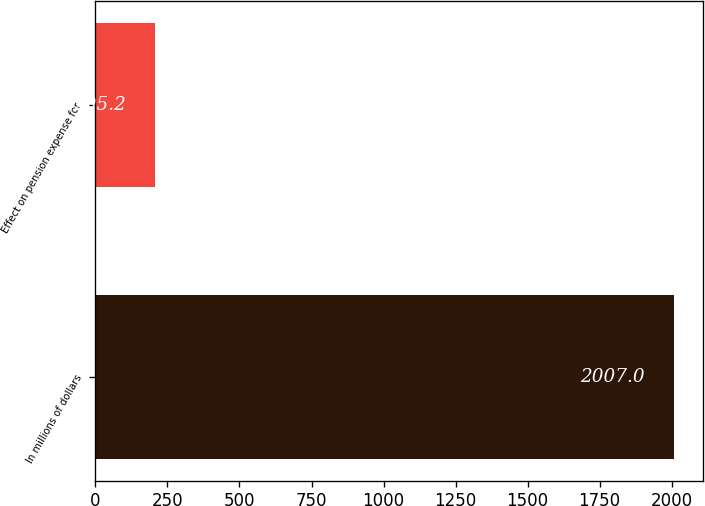Convert chart to OTSL. <chart><loc_0><loc_0><loc_500><loc_500><bar_chart><fcel>In millions of dollars<fcel>Effect on pension expense for<nl><fcel>2007<fcel>205.2<nl></chart> 